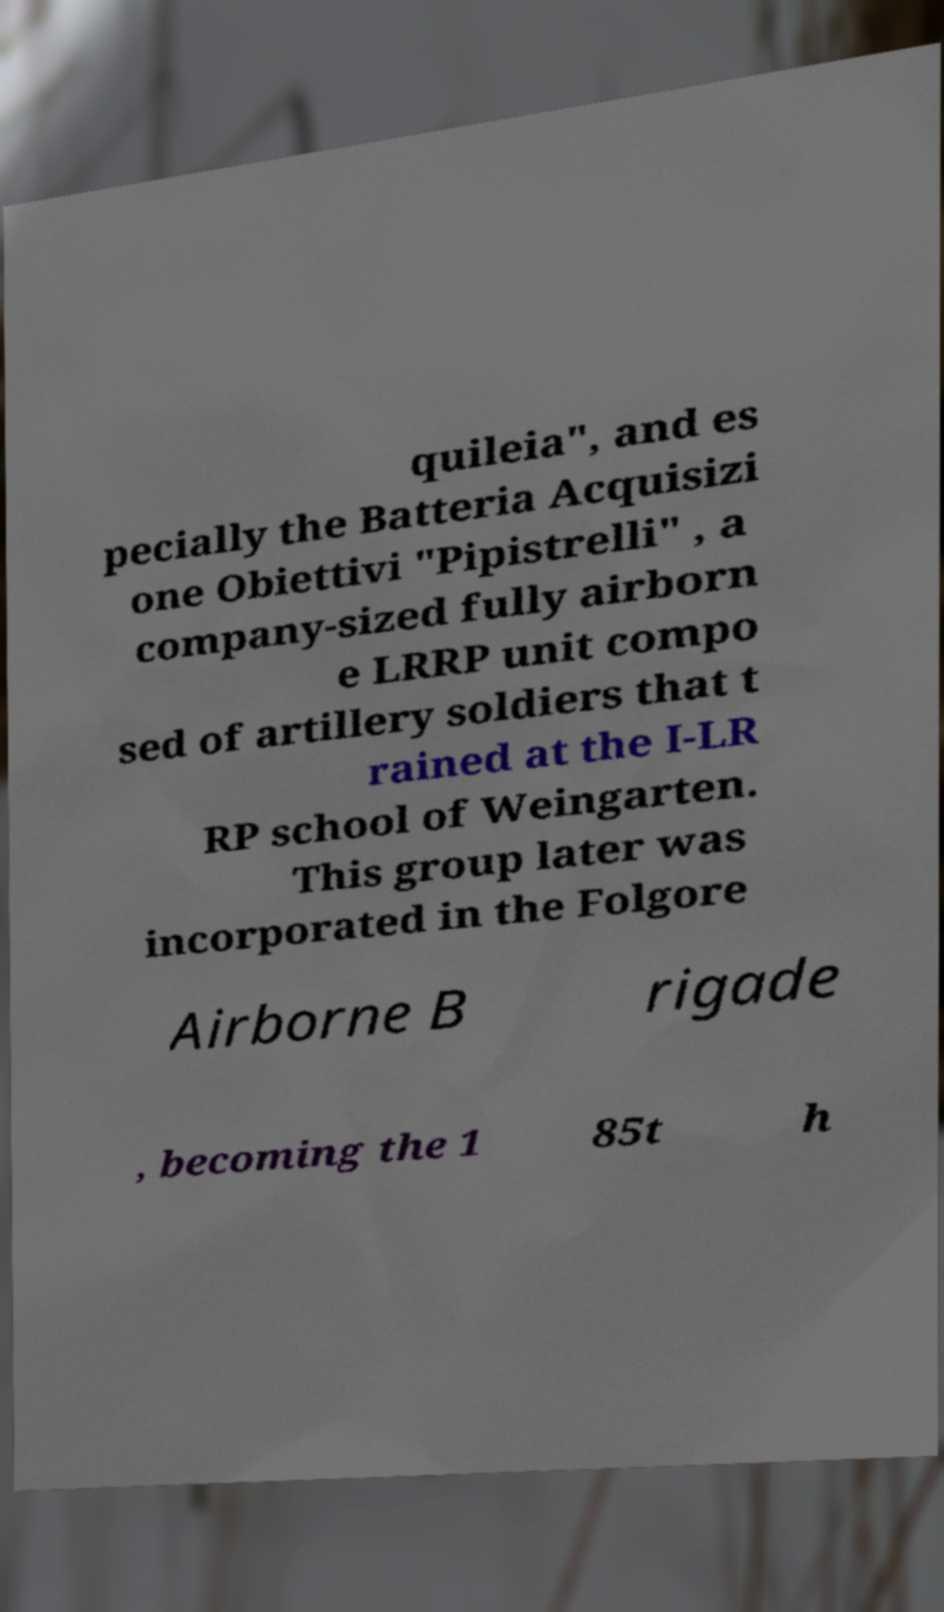For documentation purposes, I need the text within this image transcribed. Could you provide that? quileia", and es pecially the Batteria Acquisizi one Obiettivi "Pipistrelli" , a company-sized fully airborn e LRRP unit compo sed of artillery soldiers that t rained at the I-LR RP school of Weingarten. This group later was incorporated in the Folgore Airborne B rigade , becoming the 1 85t h 